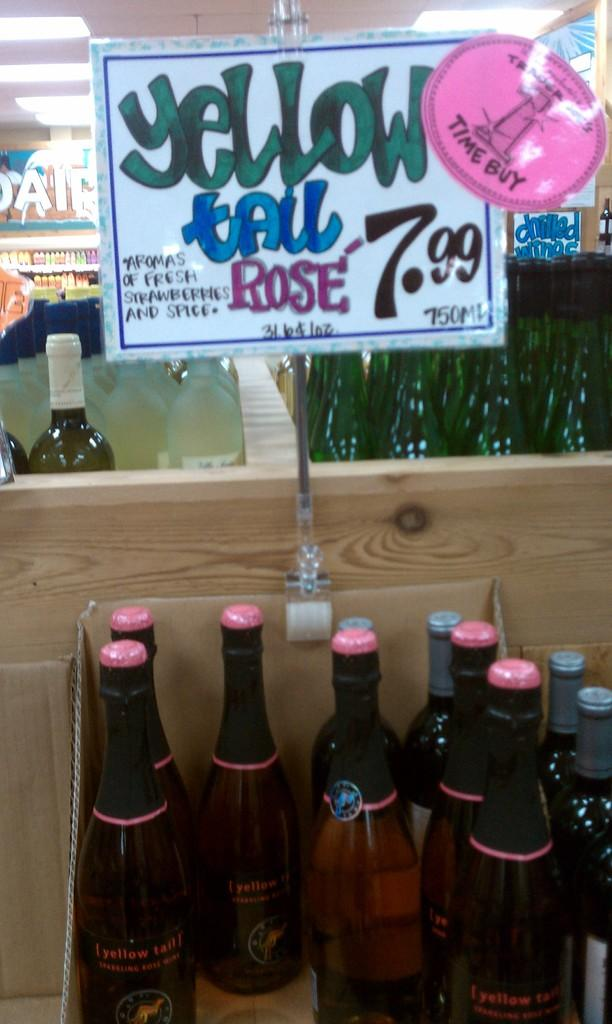What objects are stored in the box in the image? There are bottles in a box in the image. What can be seen on the board in the image? The facts provided do not specify any details about the board, so we cannot answer this question definitively. Where are additional bottles located in the image? There are bottles in a rack in the background of the image. What structure is visible in the image? There is a roof visible in the image. What illuminates the area in the image? There are lights in the image. What scientific experiment is being conducted in the image? There is no indication of a scientific experiment being conducted in the image. --- Facts: 1. There is a person in the image. 2. The person is wearing a hat. 3. The person is holding a book. 4. There is a table in the image. 5. There is a chair in the image. Absurd Topics: unicorn, ocean Conversation: Who or what is present in the image? There is a person in the image. What is the person wearing on their head? The person is wearing a hat. What object is the person holding in their hands? The person is holding a book. What type of furniture is visible in the image? There is a table and a chair in the image. Reasoning: Let's think step by step in order to produce the conversation. We start by identifying the main subject of the image, which is the person. Next, we describe specific features of the person, such as the hat and the book they are holding. Then, we observe the furniture in the image, noting that there is a table and a chair. Finally, we ensure that the language is simple and clear. Absurd Question/Answer: Can you see a unicorn in the image? No, there is no unicorn present in the image. --- Facts: 1. There is a dog in the image. 2. The dog is sitting on a rug. 3. The dog has a collar. 4. There is a bowl of water next to the dog. 5. There is a window in the background of the image. Absurd Topics: spaceship Conversation: What type of animal is present in the image? There is a dog in the image. What position is the dog in? The dog is sitting on a rug. Does the dog have any accessories? Yes, the dog has a collar. What object is next to the dog? There is a bowl of water next to the dog. What can be seen in the background of the image? There is a window in the background of the image. Reasoning: Let's think step by step in order to produce the conversation. We start by identifying the main subject of the image, which is the dog. Next, we describe specific features 